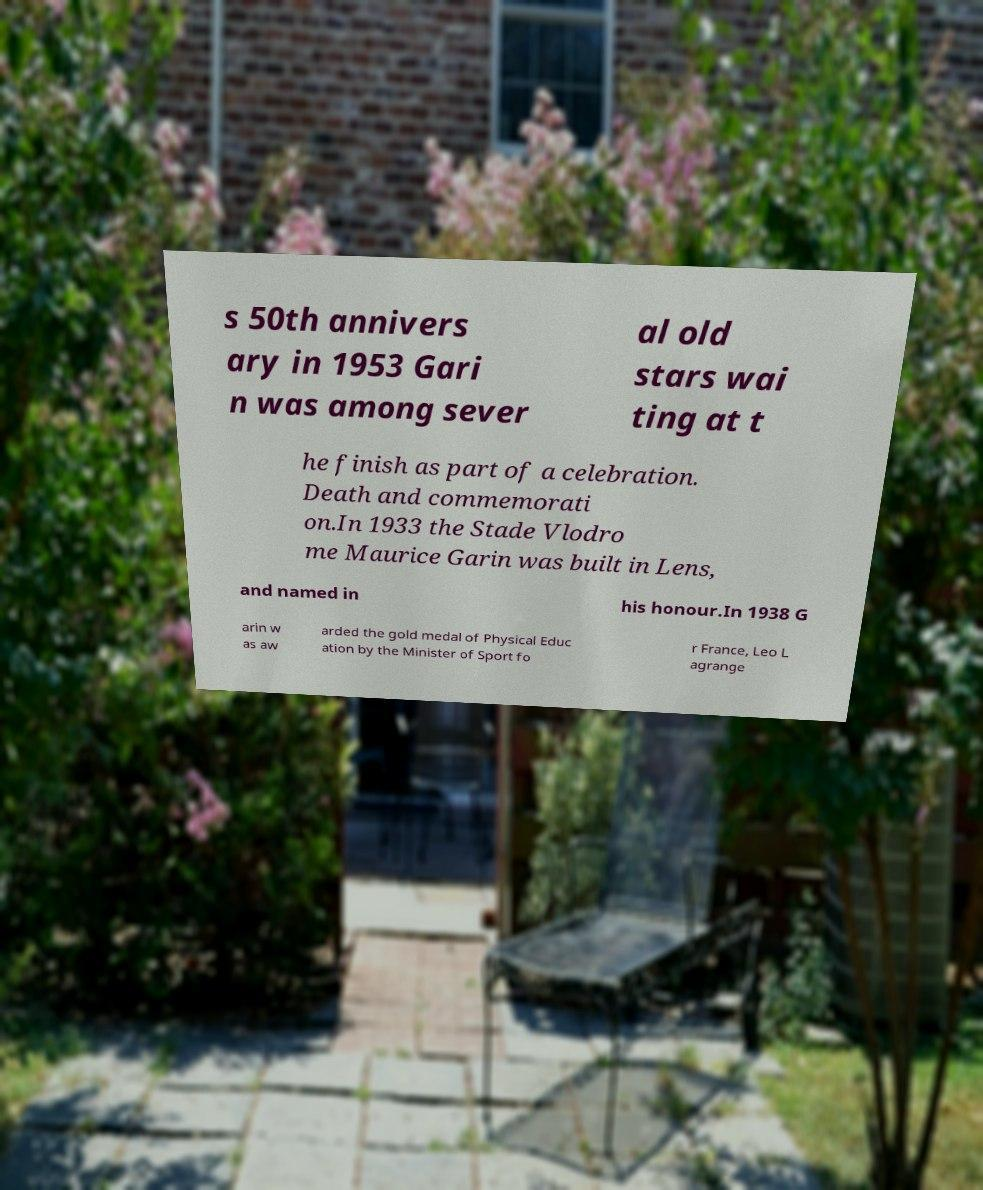There's text embedded in this image that I need extracted. Can you transcribe it verbatim? s 50th annivers ary in 1953 Gari n was among sever al old stars wai ting at t he finish as part of a celebration. Death and commemorati on.In 1933 the Stade Vlodro me Maurice Garin was built in Lens, and named in his honour.In 1938 G arin w as aw arded the gold medal of Physical Educ ation by the Minister of Sport fo r France, Leo L agrange 